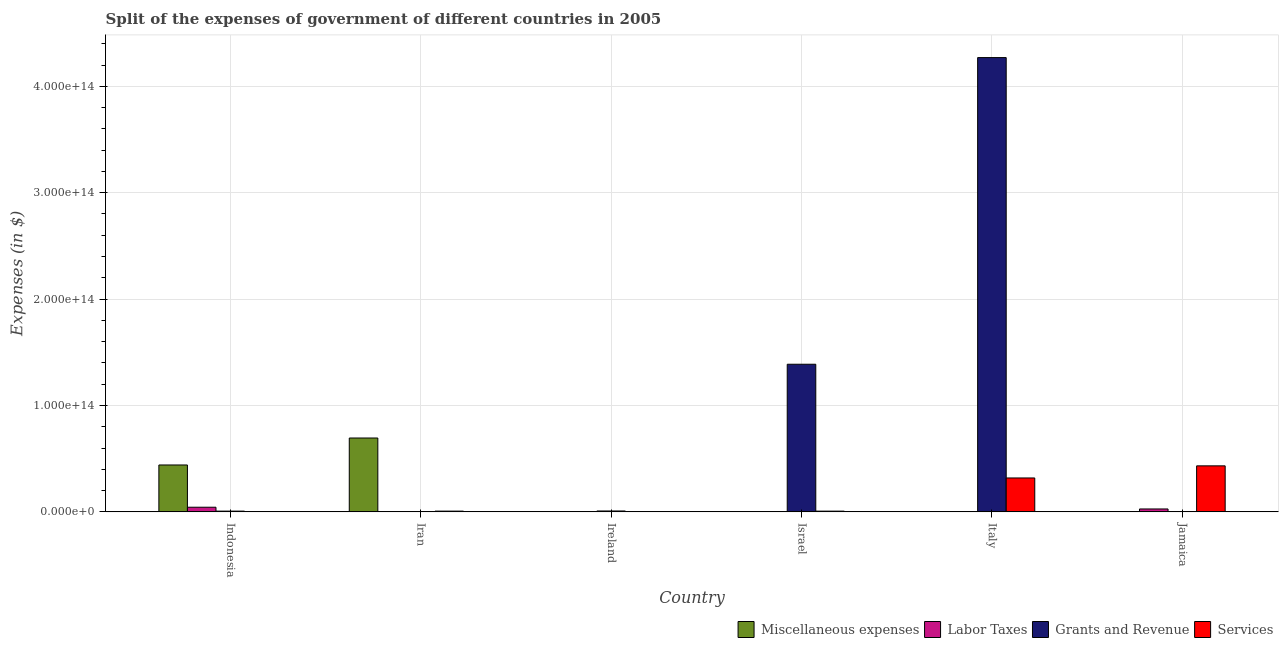How many groups of bars are there?
Provide a succinct answer. 6. Are the number of bars per tick equal to the number of legend labels?
Provide a short and direct response. Yes. How many bars are there on the 5th tick from the right?
Ensure brevity in your answer.  4. What is the label of the 2nd group of bars from the left?
Offer a very short reply. Iran. In how many cases, is the number of bars for a given country not equal to the number of legend labels?
Keep it short and to the point. 0. What is the amount spent on miscellaneous expenses in Ireland?
Your answer should be compact. 7.97e+08. Across all countries, what is the maximum amount spent on services?
Your answer should be very brief. 4.33e+13. Across all countries, what is the minimum amount spent on miscellaneous expenses?
Ensure brevity in your answer.  7.97e+08. In which country was the amount spent on miscellaneous expenses maximum?
Offer a very short reply. Iran. In which country was the amount spent on grants and revenue minimum?
Offer a very short reply. Jamaica. What is the total amount spent on grants and revenue in the graph?
Your answer should be very brief. 5.67e+14. What is the difference between the amount spent on labor taxes in Iran and that in Jamaica?
Offer a very short reply. -2.73e+12. What is the difference between the amount spent on labor taxes in Israel and the amount spent on grants and revenue in Ireland?
Ensure brevity in your answer.  -8.16e+11. What is the average amount spent on labor taxes per country?
Keep it short and to the point. 1.19e+12. What is the difference between the amount spent on grants and revenue and amount spent on miscellaneous expenses in Italy?
Ensure brevity in your answer.  4.27e+14. What is the ratio of the amount spent on miscellaneous expenses in Iran to that in Jamaica?
Ensure brevity in your answer.  1079.53. Is the amount spent on miscellaneous expenses in Italy less than that in Jamaica?
Your answer should be compact. Yes. Is the difference between the amount spent on labor taxes in Iran and Israel greater than the difference between the amount spent on miscellaneous expenses in Iran and Israel?
Give a very brief answer. No. What is the difference between the highest and the second highest amount spent on labor taxes?
Your answer should be very brief. 1.63e+12. What is the difference between the highest and the lowest amount spent on labor taxes?
Ensure brevity in your answer.  4.36e+12. What does the 4th bar from the left in Ireland represents?
Offer a very short reply. Services. What does the 4th bar from the right in Jamaica represents?
Ensure brevity in your answer.  Miscellaneous expenses. Is it the case that in every country, the sum of the amount spent on miscellaneous expenses and amount spent on labor taxes is greater than the amount spent on grants and revenue?
Provide a short and direct response. No. How many bars are there?
Ensure brevity in your answer.  24. How many countries are there in the graph?
Give a very brief answer. 6. What is the difference between two consecutive major ticks on the Y-axis?
Offer a terse response. 1.00e+14. Are the values on the major ticks of Y-axis written in scientific E-notation?
Your answer should be very brief. Yes. Does the graph contain any zero values?
Your answer should be compact. No. How many legend labels are there?
Your answer should be very brief. 4. How are the legend labels stacked?
Your response must be concise. Horizontal. What is the title of the graph?
Offer a very short reply. Split of the expenses of government of different countries in 2005. What is the label or title of the Y-axis?
Make the answer very short. Expenses (in $). What is the Expenses (in $) in Miscellaneous expenses in Indonesia?
Offer a terse response. 4.41e+13. What is the Expenses (in $) in Labor Taxes in Indonesia?
Your response must be concise. 4.36e+12. What is the Expenses (in $) in Grants and Revenue in Indonesia?
Keep it short and to the point. 7.14e+11. What is the Expenses (in $) of Services in Indonesia?
Offer a terse response. 4.87e+1. What is the Expenses (in $) in Miscellaneous expenses in Iran?
Keep it short and to the point. 6.94e+13. What is the Expenses (in $) in Labor Taxes in Iran?
Your answer should be compact. 2.83e+09. What is the Expenses (in $) of Grants and Revenue in Iran?
Your answer should be very brief. 4.34e+1. What is the Expenses (in $) in Services in Iran?
Your answer should be compact. 7.18e+11. What is the Expenses (in $) of Miscellaneous expenses in Ireland?
Give a very brief answer. 7.97e+08. What is the Expenses (in $) of Labor Taxes in Ireland?
Your answer should be very brief. 1.44e+1. What is the Expenses (in $) in Grants and Revenue in Ireland?
Your response must be concise. 8.41e+11. What is the Expenses (in $) in Services in Ireland?
Give a very brief answer. 7.61e+1. What is the Expenses (in $) of Miscellaneous expenses in Israel?
Provide a short and direct response. 2.11e+1. What is the Expenses (in $) in Labor Taxes in Israel?
Offer a terse response. 2.44e+1. What is the Expenses (in $) in Grants and Revenue in Israel?
Ensure brevity in your answer.  1.39e+14. What is the Expenses (in $) in Services in Israel?
Keep it short and to the point. 6.98e+11. What is the Expenses (in $) of Miscellaneous expenses in Italy?
Your answer should be very brief. 3.03e+1. What is the Expenses (in $) in Labor Taxes in Italy?
Provide a short and direct response. 2.14e+1. What is the Expenses (in $) of Grants and Revenue in Italy?
Keep it short and to the point. 4.27e+14. What is the Expenses (in $) in Services in Italy?
Your answer should be compact. 3.19e+13. What is the Expenses (in $) of Miscellaneous expenses in Jamaica?
Keep it short and to the point. 6.43e+1. What is the Expenses (in $) of Labor Taxes in Jamaica?
Ensure brevity in your answer.  2.73e+12. What is the Expenses (in $) of Grants and Revenue in Jamaica?
Your answer should be compact. 4.33e+1. What is the Expenses (in $) in Services in Jamaica?
Make the answer very short. 4.33e+13. Across all countries, what is the maximum Expenses (in $) of Miscellaneous expenses?
Offer a terse response. 6.94e+13. Across all countries, what is the maximum Expenses (in $) in Labor Taxes?
Your answer should be very brief. 4.36e+12. Across all countries, what is the maximum Expenses (in $) of Grants and Revenue?
Ensure brevity in your answer.  4.27e+14. Across all countries, what is the maximum Expenses (in $) in Services?
Your response must be concise. 4.33e+13. Across all countries, what is the minimum Expenses (in $) of Miscellaneous expenses?
Offer a very short reply. 7.97e+08. Across all countries, what is the minimum Expenses (in $) in Labor Taxes?
Offer a terse response. 2.83e+09. Across all countries, what is the minimum Expenses (in $) of Grants and Revenue?
Provide a short and direct response. 4.33e+1. Across all countries, what is the minimum Expenses (in $) in Services?
Offer a very short reply. 4.87e+1. What is the total Expenses (in $) in Miscellaneous expenses in the graph?
Provide a succinct answer. 1.14e+14. What is the total Expenses (in $) of Labor Taxes in the graph?
Provide a short and direct response. 7.16e+12. What is the total Expenses (in $) of Grants and Revenue in the graph?
Offer a terse response. 5.67e+14. What is the total Expenses (in $) in Services in the graph?
Make the answer very short. 7.67e+13. What is the difference between the Expenses (in $) of Miscellaneous expenses in Indonesia and that in Iran?
Offer a terse response. -2.53e+13. What is the difference between the Expenses (in $) in Labor Taxes in Indonesia and that in Iran?
Keep it short and to the point. 4.36e+12. What is the difference between the Expenses (in $) in Grants and Revenue in Indonesia and that in Iran?
Provide a short and direct response. 6.71e+11. What is the difference between the Expenses (in $) of Services in Indonesia and that in Iran?
Give a very brief answer. -6.69e+11. What is the difference between the Expenses (in $) of Miscellaneous expenses in Indonesia and that in Ireland?
Give a very brief answer. 4.41e+13. What is the difference between the Expenses (in $) of Labor Taxes in Indonesia and that in Ireland?
Your response must be concise. 4.35e+12. What is the difference between the Expenses (in $) in Grants and Revenue in Indonesia and that in Ireland?
Offer a very short reply. -1.27e+11. What is the difference between the Expenses (in $) in Services in Indonesia and that in Ireland?
Ensure brevity in your answer.  -2.74e+1. What is the difference between the Expenses (in $) of Miscellaneous expenses in Indonesia and that in Israel?
Make the answer very short. 4.41e+13. What is the difference between the Expenses (in $) in Labor Taxes in Indonesia and that in Israel?
Make the answer very short. 4.34e+12. What is the difference between the Expenses (in $) in Grants and Revenue in Indonesia and that in Israel?
Your response must be concise. -1.38e+14. What is the difference between the Expenses (in $) in Services in Indonesia and that in Israel?
Your response must be concise. -6.50e+11. What is the difference between the Expenses (in $) of Miscellaneous expenses in Indonesia and that in Italy?
Make the answer very short. 4.41e+13. What is the difference between the Expenses (in $) of Labor Taxes in Indonesia and that in Italy?
Provide a short and direct response. 4.34e+12. What is the difference between the Expenses (in $) of Grants and Revenue in Indonesia and that in Italy?
Your response must be concise. -4.26e+14. What is the difference between the Expenses (in $) of Services in Indonesia and that in Italy?
Give a very brief answer. -3.18e+13. What is the difference between the Expenses (in $) of Miscellaneous expenses in Indonesia and that in Jamaica?
Your response must be concise. 4.40e+13. What is the difference between the Expenses (in $) of Labor Taxes in Indonesia and that in Jamaica?
Offer a terse response. 1.63e+12. What is the difference between the Expenses (in $) of Grants and Revenue in Indonesia and that in Jamaica?
Provide a short and direct response. 6.71e+11. What is the difference between the Expenses (in $) of Services in Indonesia and that in Jamaica?
Your response must be concise. -4.32e+13. What is the difference between the Expenses (in $) in Miscellaneous expenses in Iran and that in Ireland?
Your answer should be very brief. 6.94e+13. What is the difference between the Expenses (in $) in Labor Taxes in Iran and that in Ireland?
Your answer should be very brief. -1.16e+1. What is the difference between the Expenses (in $) in Grants and Revenue in Iran and that in Ireland?
Provide a succinct answer. -7.97e+11. What is the difference between the Expenses (in $) of Services in Iran and that in Ireland?
Give a very brief answer. 6.42e+11. What is the difference between the Expenses (in $) in Miscellaneous expenses in Iran and that in Israel?
Give a very brief answer. 6.94e+13. What is the difference between the Expenses (in $) of Labor Taxes in Iran and that in Israel?
Give a very brief answer. -2.16e+1. What is the difference between the Expenses (in $) of Grants and Revenue in Iran and that in Israel?
Your answer should be compact. -1.39e+14. What is the difference between the Expenses (in $) in Services in Iran and that in Israel?
Make the answer very short. 1.98e+1. What is the difference between the Expenses (in $) in Miscellaneous expenses in Iran and that in Italy?
Provide a succinct answer. 6.94e+13. What is the difference between the Expenses (in $) of Labor Taxes in Iran and that in Italy?
Your answer should be very brief. -1.85e+1. What is the difference between the Expenses (in $) of Grants and Revenue in Iran and that in Italy?
Your answer should be compact. -4.27e+14. What is the difference between the Expenses (in $) of Services in Iran and that in Italy?
Your response must be concise. -3.11e+13. What is the difference between the Expenses (in $) of Miscellaneous expenses in Iran and that in Jamaica?
Give a very brief answer. 6.94e+13. What is the difference between the Expenses (in $) in Labor Taxes in Iran and that in Jamaica?
Give a very brief answer. -2.73e+12. What is the difference between the Expenses (in $) in Grants and Revenue in Iran and that in Jamaica?
Offer a terse response. 1.68e+08. What is the difference between the Expenses (in $) in Services in Iran and that in Jamaica?
Offer a very short reply. -4.25e+13. What is the difference between the Expenses (in $) of Miscellaneous expenses in Ireland and that in Israel?
Provide a succinct answer. -2.03e+1. What is the difference between the Expenses (in $) in Labor Taxes in Ireland and that in Israel?
Keep it short and to the point. -1.00e+1. What is the difference between the Expenses (in $) of Grants and Revenue in Ireland and that in Israel?
Your response must be concise. -1.38e+14. What is the difference between the Expenses (in $) in Services in Ireland and that in Israel?
Make the answer very short. -6.22e+11. What is the difference between the Expenses (in $) of Miscellaneous expenses in Ireland and that in Italy?
Offer a very short reply. -2.95e+1. What is the difference between the Expenses (in $) of Labor Taxes in Ireland and that in Italy?
Your answer should be very brief. -6.94e+09. What is the difference between the Expenses (in $) in Grants and Revenue in Ireland and that in Italy?
Give a very brief answer. -4.26e+14. What is the difference between the Expenses (in $) of Services in Ireland and that in Italy?
Ensure brevity in your answer.  -3.18e+13. What is the difference between the Expenses (in $) of Miscellaneous expenses in Ireland and that in Jamaica?
Make the answer very short. -6.35e+1. What is the difference between the Expenses (in $) in Labor Taxes in Ireland and that in Jamaica?
Your answer should be very brief. -2.72e+12. What is the difference between the Expenses (in $) in Grants and Revenue in Ireland and that in Jamaica?
Your answer should be very brief. 7.97e+11. What is the difference between the Expenses (in $) in Services in Ireland and that in Jamaica?
Give a very brief answer. -4.32e+13. What is the difference between the Expenses (in $) of Miscellaneous expenses in Israel and that in Italy?
Offer a terse response. -9.17e+09. What is the difference between the Expenses (in $) of Labor Taxes in Israel and that in Italy?
Offer a terse response. 3.07e+09. What is the difference between the Expenses (in $) in Grants and Revenue in Israel and that in Italy?
Your answer should be compact. -2.88e+14. What is the difference between the Expenses (in $) in Services in Israel and that in Italy?
Offer a very short reply. -3.12e+13. What is the difference between the Expenses (in $) of Miscellaneous expenses in Israel and that in Jamaica?
Keep it short and to the point. -4.32e+1. What is the difference between the Expenses (in $) of Labor Taxes in Israel and that in Jamaica?
Offer a very short reply. -2.71e+12. What is the difference between the Expenses (in $) of Grants and Revenue in Israel and that in Jamaica?
Your answer should be very brief. 1.39e+14. What is the difference between the Expenses (in $) of Services in Israel and that in Jamaica?
Keep it short and to the point. -4.26e+13. What is the difference between the Expenses (in $) of Miscellaneous expenses in Italy and that in Jamaica?
Make the answer very short. -3.40e+1. What is the difference between the Expenses (in $) in Labor Taxes in Italy and that in Jamaica?
Offer a very short reply. -2.71e+12. What is the difference between the Expenses (in $) of Grants and Revenue in Italy and that in Jamaica?
Provide a succinct answer. 4.27e+14. What is the difference between the Expenses (in $) in Services in Italy and that in Jamaica?
Make the answer very short. -1.14e+13. What is the difference between the Expenses (in $) in Miscellaneous expenses in Indonesia and the Expenses (in $) in Labor Taxes in Iran?
Your answer should be very brief. 4.41e+13. What is the difference between the Expenses (in $) in Miscellaneous expenses in Indonesia and the Expenses (in $) in Grants and Revenue in Iran?
Your response must be concise. 4.40e+13. What is the difference between the Expenses (in $) in Miscellaneous expenses in Indonesia and the Expenses (in $) in Services in Iran?
Offer a very short reply. 4.34e+13. What is the difference between the Expenses (in $) in Labor Taxes in Indonesia and the Expenses (in $) in Grants and Revenue in Iran?
Your answer should be very brief. 4.32e+12. What is the difference between the Expenses (in $) in Labor Taxes in Indonesia and the Expenses (in $) in Services in Iran?
Your response must be concise. 3.64e+12. What is the difference between the Expenses (in $) of Grants and Revenue in Indonesia and the Expenses (in $) of Services in Iran?
Your answer should be compact. -3.87e+09. What is the difference between the Expenses (in $) of Miscellaneous expenses in Indonesia and the Expenses (in $) of Labor Taxes in Ireland?
Make the answer very short. 4.41e+13. What is the difference between the Expenses (in $) of Miscellaneous expenses in Indonesia and the Expenses (in $) of Grants and Revenue in Ireland?
Ensure brevity in your answer.  4.32e+13. What is the difference between the Expenses (in $) in Miscellaneous expenses in Indonesia and the Expenses (in $) in Services in Ireland?
Your answer should be compact. 4.40e+13. What is the difference between the Expenses (in $) in Labor Taxes in Indonesia and the Expenses (in $) in Grants and Revenue in Ireland?
Offer a very short reply. 3.52e+12. What is the difference between the Expenses (in $) in Labor Taxes in Indonesia and the Expenses (in $) in Services in Ireland?
Make the answer very short. 4.29e+12. What is the difference between the Expenses (in $) in Grants and Revenue in Indonesia and the Expenses (in $) in Services in Ireland?
Provide a short and direct response. 6.38e+11. What is the difference between the Expenses (in $) in Miscellaneous expenses in Indonesia and the Expenses (in $) in Labor Taxes in Israel?
Offer a very short reply. 4.41e+13. What is the difference between the Expenses (in $) in Miscellaneous expenses in Indonesia and the Expenses (in $) in Grants and Revenue in Israel?
Provide a succinct answer. -9.47e+13. What is the difference between the Expenses (in $) in Miscellaneous expenses in Indonesia and the Expenses (in $) in Services in Israel?
Provide a short and direct response. 4.34e+13. What is the difference between the Expenses (in $) in Labor Taxes in Indonesia and the Expenses (in $) in Grants and Revenue in Israel?
Provide a short and direct response. -1.34e+14. What is the difference between the Expenses (in $) in Labor Taxes in Indonesia and the Expenses (in $) in Services in Israel?
Your answer should be compact. 3.66e+12. What is the difference between the Expenses (in $) of Grants and Revenue in Indonesia and the Expenses (in $) of Services in Israel?
Make the answer very short. 1.59e+1. What is the difference between the Expenses (in $) of Miscellaneous expenses in Indonesia and the Expenses (in $) of Labor Taxes in Italy?
Give a very brief answer. 4.41e+13. What is the difference between the Expenses (in $) in Miscellaneous expenses in Indonesia and the Expenses (in $) in Grants and Revenue in Italy?
Your answer should be very brief. -3.83e+14. What is the difference between the Expenses (in $) of Miscellaneous expenses in Indonesia and the Expenses (in $) of Services in Italy?
Your answer should be compact. 1.22e+13. What is the difference between the Expenses (in $) of Labor Taxes in Indonesia and the Expenses (in $) of Grants and Revenue in Italy?
Offer a very short reply. -4.23e+14. What is the difference between the Expenses (in $) in Labor Taxes in Indonesia and the Expenses (in $) in Services in Italy?
Keep it short and to the point. -2.75e+13. What is the difference between the Expenses (in $) of Grants and Revenue in Indonesia and the Expenses (in $) of Services in Italy?
Your answer should be compact. -3.12e+13. What is the difference between the Expenses (in $) of Miscellaneous expenses in Indonesia and the Expenses (in $) of Labor Taxes in Jamaica?
Your answer should be very brief. 4.13e+13. What is the difference between the Expenses (in $) of Miscellaneous expenses in Indonesia and the Expenses (in $) of Grants and Revenue in Jamaica?
Keep it short and to the point. 4.40e+13. What is the difference between the Expenses (in $) of Miscellaneous expenses in Indonesia and the Expenses (in $) of Services in Jamaica?
Your answer should be compact. 8.22e+11. What is the difference between the Expenses (in $) in Labor Taxes in Indonesia and the Expenses (in $) in Grants and Revenue in Jamaica?
Make the answer very short. 4.32e+12. What is the difference between the Expenses (in $) in Labor Taxes in Indonesia and the Expenses (in $) in Services in Jamaica?
Your answer should be compact. -3.89e+13. What is the difference between the Expenses (in $) of Grants and Revenue in Indonesia and the Expenses (in $) of Services in Jamaica?
Offer a terse response. -4.25e+13. What is the difference between the Expenses (in $) in Miscellaneous expenses in Iran and the Expenses (in $) in Labor Taxes in Ireland?
Offer a terse response. 6.94e+13. What is the difference between the Expenses (in $) in Miscellaneous expenses in Iran and the Expenses (in $) in Grants and Revenue in Ireland?
Provide a succinct answer. 6.86e+13. What is the difference between the Expenses (in $) in Miscellaneous expenses in Iran and the Expenses (in $) in Services in Ireland?
Give a very brief answer. 6.94e+13. What is the difference between the Expenses (in $) of Labor Taxes in Iran and the Expenses (in $) of Grants and Revenue in Ireland?
Provide a succinct answer. -8.38e+11. What is the difference between the Expenses (in $) in Labor Taxes in Iran and the Expenses (in $) in Services in Ireland?
Offer a terse response. -7.33e+1. What is the difference between the Expenses (in $) of Grants and Revenue in Iran and the Expenses (in $) of Services in Ireland?
Offer a very short reply. -3.27e+1. What is the difference between the Expenses (in $) of Miscellaneous expenses in Iran and the Expenses (in $) of Labor Taxes in Israel?
Your answer should be compact. 6.94e+13. What is the difference between the Expenses (in $) in Miscellaneous expenses in Iran and the Expenses (in $) in Grants and Revenue in Israel?
Provide a short and direct response. -6.93e+13. What is the difference between the Expenses (in $) of Miscellaneous expenses in Iran and the Expenses (in $) of Services in Israel?
Your answer should be compact. 6.87e+13. What is the difference between the Expenses (in $) in Labor Taxes in Iran and the Expenses (in $) in Grants and Revenue in Israel?
Keep it short and to the point. -1.39e+14. What is the difference between the Expenses (in $) of Labor Taxes in Iran and the Expenses (in $) of Services in Israel?
Provide a short and direct response. -6.95e+11. What is the difference between the Expenses (in $) of Grants and Revenue in Iran and the Expenses (in $) of Services in Israel?
Offer a very short reply. -6.55e+11. What is the difference between the Expenses (in $) in Miscellaneous expenses in Iran and the Expenses (in $) in Labor Taxes in Italy?
Ensure brevity in your answer.  6.94e+13. What is the difference between the Expenses (in $) of Miscellaneous expenses in Iran and the Expenses (in $) of Grants and Revenue in Italy?
Provide a succinct answer. -3.58e+14. What is the difference between the Expenses (in $) of Miscellaneous expenses in Iran and the Expenses (in $) of Services in Italy?
Your response must be concise. 3.76e+13. What is the difference between the Expenses (in $) in Labor Taxes in Iran and the Expenses (in $) in Grants and Revenue in Italy?
Your answer should be compact. -4.27e+14. What is the difference between the Expenses (in $) in Labor Taxes in Iran and the Expenses (in $) in Services in Italy?
Your answer should be very brief. -3.19e+13. What is the difference between the Expenses (in $) of Grants and Revenue in Iran and the Expenses (in $) of Services in Italy?
Provide a short and direct response. -3.18e+13. What is the difference between the Expenses (in $) of Miscellaneous expenses in Iran and the Expenses (in $) of Labor Taxes in Jamaica?
Make the answer very short. 6.67e+13. What is the difference between the Expenses (in $) in Miscellaneous expenses in Iran and the Expenses (in $) in Grants and Revenue in Jamaica?
Your answer should be compact. 6.94e+13. What is the difference between the Expenses (in $) of Miscellaneous expenses in Iran and the Expenses (in $) of Services in Jamaica?
Keep it short and to the point. 2.62e+13. What is the difference between the Expenses (in $) of Labor Taxes in Iran and the Expenses (in $) of Grants and Revenue in Jamaica?
Your response must be concise. -4.04e+1. What is the difference between the Expenses (in $) of Labor Taxes in Iran and the Expenses (in $) of Services in Jamaica?
Offer a terse response. -4.33e+13. What is the difference between the Expenses (in $) in Grants and Revenue in Iran and the Expenses (in $) in Services in Jamaica?
Provide a succinct answer. -4.32e+13. What is the difference between the Expenses (in $) in Miscellaneous expenses in Ireland and the Expenses (in $) in Labor Taxes in Israel?
Provide a succinct answer. -2.36e+1. What is the difference between the Expenses (in $) in Miscellaneous expenses in Ireland and the Expenses (in $) in Grants and Revenue in Israel?
Provide a succinct answer. -1.39e+14. What is the difference between the Expenses (in $) in Miscellaneous expenses in Ireland and the Expenses (in $) in Services in Israel?
Your response must be concise. -6.98e+11. What is the difference between the Expenses (in $) of Labor Taxes in Ireland and the Expenses (in $) of Grants and Revenue in Israel?
Your answer should be very brief. -1.39e+14. What is the difference between the Expenses (in $) in Labor Taxes in Ireland and the Expenses (in $) in Services in Israel?
Offer a very short reply. -6.84e+11. What is the difference between the Expenses (in $) in Grants and Revenue in Ireland and the Expenses (in $) in Services in Israel?
Provide a succinct answer. 1.42e+11. What is the difference between the Expenses (in $) of Miscellaneous expenses in Ireland and the Expenses (in $) of Labor Taxes in Italy?
Your response must be concise. -2.06e+1. What is the difference between the Expenses (in $) of Miscellaneous expenses in Ireland and the Expenses (in $) of Grants and Revenue in Italy?
Provide a short and direct response. -4.27e+14. What is the difference between the Expenses (in $) in Miscellaneous expenses in Ireland and the Expenses (in $) in Services in Italy?
Your answer should be compact. -3.19e+13. What is the difference between the Expenses (in $) of Labor Taxes in Ireland and the Expenses (in $) of Grants and Revenue in Italy?
Your response must be concise. -4.27e+14. What is the difference between the Expenses (in $) of Labor Taxes in Ireland and the Expenses (in $) of Services in Italy?
Your answer should be very brief. -3.19e+13. What is the difference between the Expenses (in $) of Grants and Revenue in Ireland and the Expenses (in $) of Services in Italy?
Provide a succinct answer. -3.10e+13. What is the difference between the Expenses (in $) in Miscellaneous expenses in Ireland and the Expenses (in $) in Labor Taxes in Jamaica?
Offer a very short reply. -2.73e+12. What is the difference between the Expenses (in $) of Miscellaneous expenses in Ireland and the Expenses (in $) of Grants and Revenue in Jamaica?
Your answer should be compact. -4.25e+1. What is the difference between the Expenses (in $) in Miscellaneous expenses in Ireland and the Expenses (in $) in Services in Jamaica?
Offer a very short reply. -4.33e+13. What is the difference between the Expenses (in $) of Labor Taxes in Ireland and the Expenses (in $) of Grants and Revenue in Jamaica?
Your answer should be very brief. -2.89e+1. What is the difference between the Expenses (in $) in Labor Taxes in Ireland and the Expenses (in $) in Services in Jamaica?
Give a very brief answer. -4.32e+13. What is the difference between the Expenses (in $) in Grants and Revenue in Ireland and the Expenses (in $) in Services in Jamaica?
Keep it short and to the point. -4.24e+13. What is the difference between the Expenses (in $) in Miscellaneous expenses in Israel and the Expenses (in $) in Labor Taxes in Italy?
Ensure brevity in your answer.  -2.46e+08. What is the difference between the Expenses (in $) of Miscellaneous expenses in Israel and the Expenses (in $) of Grants and Revenue in Italy?
Provide a short and direct response. -4.27e+14. What is the difference between the Expenses (in $) in Miscellaneous expenses in Israel and the Expenses (in $) in Services in Italy?
Offer a terse response. -3.18e+13. What is the difference between the Expenses (in $) of Labor Taxes in Israel and the Expenses (in $) of Grants and Revenue in Italy?
Provide a succinct answer. -4.27e+14. What is the difference between the Expenses (in $) in Labor Taxes in Israel and the Expenses (in $) in Services in Italy?
Keep it short and to the point. -3.18e+13. What is the difference between the Expenses (in $) of Grants and Revenue in Israel and the Expenses (in $) of Services in Italy?
Provide a succinct answer. 1.07e+14. What is the difference between the Expenses (in $) in Miscellaneous expenses in Israel and the Expenses (in $) in Labor Taxes in Jamaica?
Ensure brevity in your answer.  -2.71e+12. What is the difference between the Expenses (in $) in Miscellaneous expenses in Israel and the Expenses (in $) in Grants and Revenue in Jamaica?
Make the answer very short. -2.22e+1. What is the difference between the Expenses (in $) of Miscellaneous expenses in Israel and the Expenses (in $) of Services in Jamaica?
Make the answer very short. -4.32e+13. What is the difference between the Expenses (in $) in Labor Taxes in Israel and the Expenses (in $) in Grants and Revenue in Jamaica?
Offer a terse response. -1.88e+1. What is the difference between the Expenses (in $) in Labor Taxes in Israel and the Expenses (in $) in Services in Jamaica?
Offer a terse response. -4.32e+13. What is the difference between the Expenses (in $) in Grants and Revenue in Israel and the Expenses (in $) in Services in Jamaica?
Make the answer very short. 9.55e+13. What is the difference between the Expenses (in $) of Miscellaneous expenses in Italy and the Expenses (in $) of Labor Taxes in Jamaica?
Make the answer very short. -2.70e+12. What is the difference between the Expenses (in $) of Miscellaneous expenses in Italy and the Expenses (in $) of Grants and Revenue in Jamaica?
Ensure brevity in your answer.  -1.30e+1. What is the difference between the Expenses (in $) of Miscellaneous expenses in Italy and the Expenses (in $) of Services in Jamaica?
Your answer should be compact. -4.32e+13. What is the difference between the Expenses (in $) in Labor Taxes in Italy and the Expenses (in $) in Grants and Revenue in Jamaica?
Make the answer very short. -2.19e+1. What is the difference between the Expenses (in $) in Labor Taxes in Italy and the Expenses (in $) in Services in Jamaica?
Offer a very short reply. -4.32e+13. What is the difference between the Expenses (in $) in Grants and Revenue in Italy and the Expenses (in $) in Services in Jamaica?
Make the answer very short. 3.84e+14. What is the average Expenses (in $) in Miscellaneous expenses per country?
Keep it short and to the point. 1.89e+13. What is the average Expenses (in $) in Labor Taxes per country?
Provide a succinct answer. 1.19e+12. What is the average Expenses (in $) in Grants and Revenue per country?
Offer a very short reply. 9.46e+13. What is the average Expenses (in $) in Services per country?
Offer a very short reply. 1.28e+13. What is the difference between the Expenses (in $) of Miscellaneous expenses and Expenses (in $) of Labor Taxes in Indonesia?
Provide a short and direct response. 3.97e+13. What is the difference between the Expenses (in $) in Miscellaneous expenses and Expenses (in $) in Grants and Revenue in Indonesia?
Provide a succinct answer. 4.34e+13. What is the difference between the Expenses (in $) in Miscellaneous expenses and Expenses (in $) in Services in Indonesia?
Ensure brevity in your answer.  4.40e+13. What is the difference between the Expenses (in $) of Labor Taxes and Expenses (in $) of Grants and Revenue in Indonesia?
Keep it short and to the point. 3.65e+12. What is the difference between the Expenses (in $) in Labor Taxes and Expenses (in $) in Services in Indonesia?
Make the answer very short. 4.31e+12. What is the difference between the Expenses (in $) in Grants and Revenue and Expenses (in $) in Services in Indonesia?
Ensure brevity in your answer.  6.66e+11. What is the difference between the Expenses (in $) in Miscellaneous expenses and Expenses (in $) in Labor Taxes in Iran?
Keep it short and to the point. 6.94e+13. What is the difference between the Expenses (in $) in Miscellaneous expenses and Expenses (in $) in Grants and Revenue in Iran?
Offer a terse response. 6.94e+13. What is the difference between the Expenses (in $) of Miscellaneous expenses and Expenses (in $) of Services in Iran?
Keep it short and to the point. 6.87e+13. What is the difference between the Expenses (in $) of Labor Taxes and Expenses (in $) of Grants and Revenue in Iran?
Keep it short and to the point. -4.06e+1. What is the difference between the Expenses (in $) of Labor Taxes and Expenses (in $) of Services in Iran?
Ensure brevity in your answer.  -7.15e+11. What is the difference between the Expenses (in $) of Grants and Revenue and Expenses (in $) of Services in Iran?
Offer a very short reply. -6.75e+11. What is the difference between the Expenses (in $) in Miscellaneous expenses and Expenses (in $) in Labor Taxes in Ireland?
Offer a terse response. -1.36e+1. What is the difference between the Expenses (in $) in Miscellaneous expenses and Expenses (in $) in Grants and Revenue in Ireland?
Make the answer very short. -8.40e+11. What is the difference between the Expenses (in $) of Miscellaneous expenses and Expenses (in $) of Services in Ireland?
Offer a very short reply. -7.53e+1. What is the difference between the Expenses (in $) of Labor Taxes and Expenses (in $) of Grants and Revenue in Ireland?
Your answer should be very brief. -8.26e+11. What is the difference between the Expenses (in $) in Labor Taxes and Expenses (in $) in Services in Ireland?
Offer a very short reply. -6.17e+1. What is the difference between the Expenses (in $) of Grants and Revenue and Expenses (in $) of Services in Ireland?
Your answer should be compact. 7.65e+11. What is the difference between the Expenses (in $) of Miscellaneous expenses and Expenses (in $) of Labor Taxes in Israel?
Your answer should be compact. -3.32e+09. What is the difference between the Expenses (in $) of Miscellaneous expenses and Expenses (in $) of Grants and Revenue in Israel?
Make the answer very short. -1.39e+14. What is the difference between the Expenses (in $) in Miscellaneous expenses and Expenses (in $) in Services in Israel?
Keep it short and to the point. -6.77e+11. What is the difference between the Expenses (in $) of Labor Taxes and Expenses (in $) of Grants and Revenue in Israel?
Offer a terse response. -1.39e+14. What is the difference between the Expenses (in $) of Labor Taxes and Expenses (in $) of Services in Israel?
Provide a succinct answer. -6.74e+11. What is the difference between the Expenses (in $) in Grants and Revenue and Expenses (in $) in Services in Israel?
Offer a terse response. 1.38e+14. What is the difference between the Expenses (in $) of Miscellaneous expenses and Expenses (in $) of Labor Taxes in Italy?
Your answer should be very brief. 8.92e+09. What is the difference between the Expenses (in $) in Miscellaneous expenses and Expenses (in $) in Grants and Revenue in Italy?
Your response must be concise. -4.27e+14. What is the difference between the Expenses (in $) in Miscellaneous expenses and Expenses (in $) in Services in Italy?
Offer a terse response. -3.18e+13. What is the difference between the Expenses (in $) of Labor Taxes and Expenses (in $) of Grants and Revenue in Italy?
Your answer should be very brief. -4.27e+14. What is the difference between the Expenses (in $) in Labor Taxes and Expenses (in $) in Services in Italy?
Give a very brief answer. -3.18e+13. What is the difference between the Expenses (in $) in Grants and Revenue and Expenses (in $) in Services in Italy?
Your answer should be very brief. 3.95e+14. What is the difference between the Expenses (in $) in Miscellaneous expenses and Expenses (in $) in Labor Taxes in Jamaica?
Provide a succinct answer. -2.67e+12. What is the difference between the Expenses (in $) in Miscellaneous expenses and Expenses (in $) in Grants and Revenue in Jamaica?
Provide a succinct answer. 2.11e+1. What is the difference between the Expenses (in $) of Miscellaneous expenses and Expenses (in $) of Services in Jamaica?
Your answer should be very brief. -4.32e+13. What is the difference between the Expenses (in $) of Labor Taxes and Expenses (in $) of Grants and Revenue in Jamaica?
Your response must be concise. 2.69e+12. What is the difference between the Expenses (in $) of Labor Taxes and Expenses (in $) of Services in Jamaica?
Offer a terse response. -4.05e+13. What is the difference between the Expenses (in $) in Grants and Revenue and Expenses (in $) in Services in Jamaica?
Provide a succinct answer. -4.32e+13. What is the ratio of the Expenses (in $) in Miscellaneous expenses in Indonesia to that in Iran?
Your response must be concise. 0.63. What is the ratio of the Expenses (in $) in Labor Taxes in Indonesia to that in Iran?
Ensure brevity in your answer.  1541.35. What is the ratio of the Expenses (in $) of Grants and Revenue in Indonesia to that in Iran?
Your response must be concise. 16.45. What is the ratio of the Expenses (in $) of Services in Indonesia to that in Iran?
Keep it short and to the point. 0.07. What is the ratio of the Expenses (in $) of Miscellaneous expenses in Indonesia to that in Ireland?
Offer a very short reply. 5.53e+04. What is the ratio of the Expenses (in $) of Labor Taxes in Indonesia to that in Ireland?
Provide a succinct answer. 302.82. What is the ratio of the Expenses (in $) of Grants and Revenue in Indonesia to that in Ireland?
Provide a short and direct response. 0.85. What is the ratio of the Expenses (in $) in Services in Indonesia to that in Ireland?
Keep it short and to the point. 0.64. What is the ratio of the Expenses (in $) in Miscellaneous expenses in Indonesia to that in Israel?
Your answer should be very brief. 2088.68. What is the ratio of the Expenses (in $) in Labor Taxes in Indonesia to that in Israel?
Give a very brief answer. 178.62. What is the ratio of the Expenses (in $) of Grants and Revenue in Indonesia to that in Israel?
Keep it short and to the point. 0.01. What is the ratio of the Expenses (in $) in Services in Indonesia to that in Israel?
Your answer should be very brief. 0.07. What is the ratio of the Expenses (in $) in Miscellaneous expenses in Indonesia to that in Italy?
Your response must be concise. 1456.19. What is the ratio of the Expenses (in $) in Labor Taxes in Indonesia to that in Italy?
Your answer should be compact. 204.34. What is the ratio of the Expenses (in $) of Grants and Revenue in Indonesia to that in Italy?
Your response must be concise. 0. What is the ratio of the Expenses (in $) of Services in Indonesia to that in Italy?
Your answer should be compact. 0. What is the ratio of the Expenses (in $) of Miscellaneous expenses in Indonesia to that in Jamaica?
Offer a very short reply. 685.43. What is the ratio of the Expenses (in $) of Labor Taxes in Indonesia to that in Jamaica?
Provide a succinct answer. 1.6. What is the ratio of the Expenses (in $) of Grants and Revenue in Indonesia to that in Jamaica?
Offer a very short reply. 16.51. What is the ratio of the Expenses (in $) in Services in Indonesia to that in Jamaica?
Provide a succinct answer. 0. What is the ratio of the Expenses (in $) of Miscellaneous expenses in Iran to that in Ireland?
Offer a very short reply. 8.71e+04. What is the ratio of the Expenses (in $) in Labor Taxes in Iran to that in Ireland?
Keep it short and to the point. 0.2. What is the ratio of the Expenses (in $) of Grants and Revenue in Iran to that in Ireland?
Your answer should be very brief. 0.05. What is the ratio of the Expenses (in $) in Services in Iran to that in Ireland?
Make the answer very short. 9.44. What is the ratio of the Expenses (in $) of Miscellaneous expenses in Iran to that in Israel?
Keep it short and to the point. 3289.63. What is the ratio of the Expenses (in $) in Labor Taxes in Iran to that in Israel?
Provide a short and direct response. 0.12. What is the ratio of the Expenses (in $) of Grants and Revenue in Iran to that in Israel?
Make the answer very short. 0. What is the ratio of the Expenses (in $) of Services in Iran to that in Israel?
Offer a terse response. 1.03. What is the ratio of the Expenses (in $) in Miscellaneous expenses in Iran to that in Italy?
Ensure brevity in your answer.  2293.48. What is the ratio of the Expenses (in $) of Labor Taxes in Iran to that in Italy?
Keep it short and to the point. 0.13. What is the ratio of the Expenses (in $) in Services in Iran to that in Italy?
Your response must be concise. 0.02. What is the ratio of the Expenses (in $) of Miscellaneous expenses in Iran to that in Jamaica?
Give a very brief answer. 1079.53. What is the ratio of the Expenses (in $) of Labor Taxes in Iran to that in Jamaica?
Provide a short and direct response. 0. What is the ratio of the Expenses (in $) in Services in Iran to that in Jamaica?
Provide a short and direct response. 0.02. What is the ratio of the Expenses (in $) of Miscellaneous expenses in Ireland to that in Israel?
Offer a very short reply. 0.04. What is the ratio of the Expenses (in $) in Labor Taxes in Ireland to that in Israel?
Your response must be concise. 0.59. What is the ratio of the Expenses (in $) of Grants and Revenue in Ireland to that in Israel?
Give a very brief answer. 0.01. What is the ratio of the Expenses (in $) of Services in Ireland to that in Israel?
Offer a terse response. 0.11. What is the ratio of the Expenses (in $) of Miscellaneous expenses in Ireland to that in Italy?
Your answer should be compact. 0.03. What is the ratio of the Expenses (in $) in Labor Taxes in Ireland to that in Italy?
Give a very brief answer. 0.67. What is the ratio of the Expenses (in $) in Grants and Revenue in Ireland to that in Italy?
Your answer should be very brief. 0. What is the ratio of the Expenses (in $) in Services in Ireland to that in Italy?
Your answer should be very brief. 0. What is the ratio of the Expenses (in $) of Miscellaneous expenses in Ireland to that in Jamaica?
Offer a terse response. 0.01. What is the ratio of the Expenses (in $) in Labor Taxes in Ireland to that in Jamaica?
Offer a very short reply. 0.01. What is the ratio of the Expenses (in $) of Grants and Revenue in Ireland to that in Jamaica?
Make the answer very short. 19.43. What is the ratio of the Expenses (in $) in Services in Ireland to that in Jamaica?
Provide a succinct answer. 0. What is the ratio of the Expenses (in $) of Miscellaneous expenses in Israel to that in Italy?
Your response must be concise. 0.7. What is the ratio of the Expenses (in $) in Labor Taxes in Israel to that in Italy?
Keep it short and to the point. 1.14. What is the ratio of the Expenses (in $) in Grants and Revenue in Israel to that in Italy?
Give a very brief answer. 0.33. What is the ratio of the Expenses (in $) of Services in Israel to that in Italy?
Make the answer very short. 0.02. What is the ratio of the Expenses (in $) of Miscellaneous expenses in Israel to that in Jamaica?
Your response must be concise. 0.33. What is the ratio of the Expenses (in $) in Labor Taxes in Israel to that in Jamaica?
Give a very brief answer. 0.01. What is the ratio of the Expenses (in $) of Grants and Revenue in Israel to that in Jamaica?
Provide a short and direct response. 3207.25. What is the ratio of the Expenses (in $) in Services in Israel to that in Jamaica?
Ensure brevity in your answer.  0.02. What is the ratio of the Expenses (in $) of Miscellaneous expenses in Italy to that in Jamaica?
Offer a terse response. 0.47. What is the ratio of the Expenses (in $) in Labor Taxes in Italy to that in Jamaica?
Ensure brevity in your answer.  0.01. What is the ratio of the Expenses (in $) of Grants and Revenue in Italy to that in Jamaica?
Offer a terse response. 9869.61. What is the ratio of the Expenses (in $) of Services in Italy to that in Jamaica?
Provide a short and direct response. 0.74. What is the difference between the highest and the second highest Expenses (in $) in Miscellaneous expenses?
Provide a succinct answer. 2.53e+13. What is the difference between the highest and the second highest Expenses (in $) of Labor Taxes?
Offer a terse response. 1.63e+12. What is the difference between the highest and the second highest Expenses (in $) in Grants and Revenue?
Your answer should be compact. 2.88e+14. What is the difference between the highest and the second highest Expenses (in $) of Services?
Provide a short and direct response. 1.14e+13. What is the difference between the highest and the lowest Expenses (in $) in Miscellaneous expenses?
Your response must be concise. 6.94e+13. What is the difference between the highest and the lowest Expenses (in $) of Labor Taxes?
Offer a very short reply. 4.36e+12. What is the difference between the highest and the lowest Expenses (in $) of Grants and Revenue?
Make the answer very short. 4.27e+14. What is the difference between the highest and the lowest Expenses (in $) in Services?
Ensure brevity in your answer.  4.32e+13. 